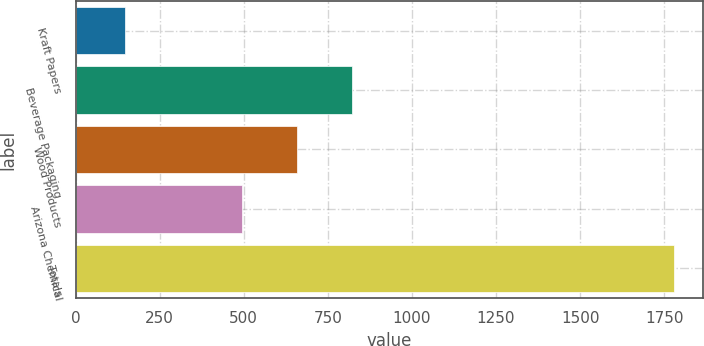Convert chart. <chart><loc_0><loc_0><loc_500><loc_500><bar_chart><fcel>Kraft Papers<fcel>Beverage Packaging<fcel>Wood Products<fcel>Arizona Chemical<fcel>Totals<nl><fcel>148<fcel>822<fcel>659<fcel>496<fcel>1778<nl></chart> 